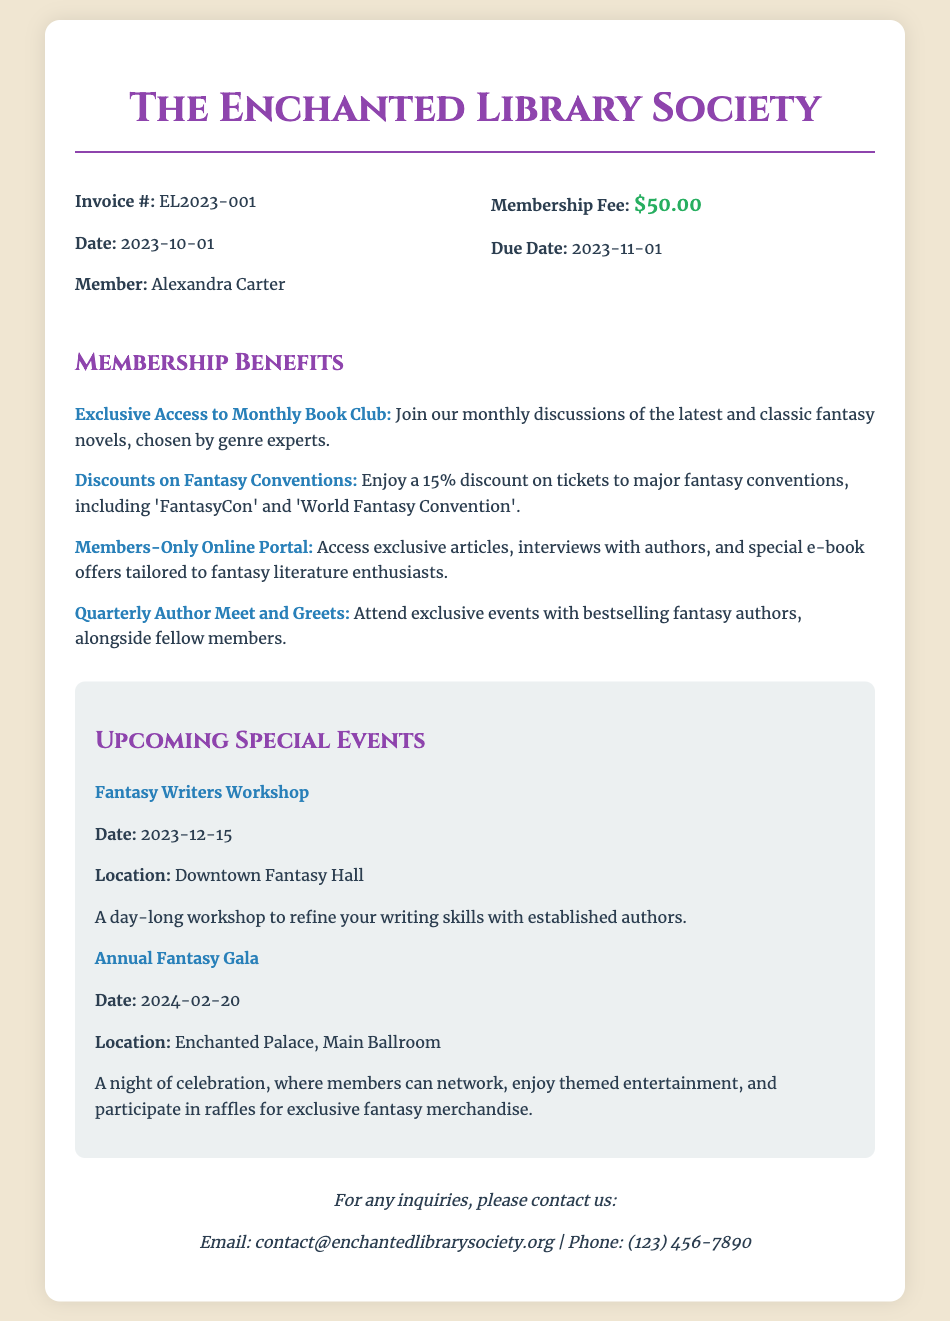What is the membership fee? The membership fee is explicitly stated in the document as $50.00.
Answer: $50.00 What is the due date for the membership fee? The due date for the membership fee is mentioned clearly in the document as 2023-11-01.
Answer: 2023-11-01 What is the name of the member? The member's name is provided in the invoice details section of the document.
Answer: Alexandra Carter What discount do members get on convention tickets? The discount on convention tickets for members is specified in the document as 15%.
Answer: 15% What is one benefit of membership related to authors? The document mentions a specific benefit regarding authors.
Answer: Quarterly Author Meet and Greets When is the Fantasy Writers Workshop scheduled? The date of the Fantasy Writers Workshop is mentioned in the events section of the document.
Answer: 2023-12-15 Where is the Annual Fantasy Gala taking place? The location of the Annual Fantasy Gala is provided in the document.
Answer: Enchanted Palace, Main Ballroom What is the event happening on 2024-02-20? The document lists events with their dates, and one is specifically designated for this date.
Answer: Annual Fantasy Gala What type of access does the Members-Only Online Portal provide? The document describes the access provided by the Members-Only Online Portal.
Answer: Exclusive articles, interviews with authors, and special e-book offers 